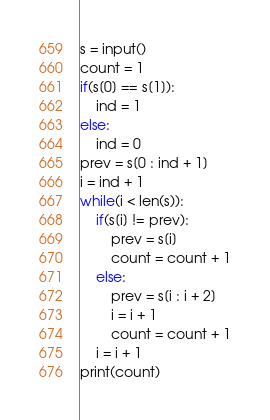Convert code to text. <code><loc_0><loc_0><loc_500><loc_500><_Python_>s = input()
count = 1
if(s[0] == s[1]):
    ind = 1
else:
    ind = 0
prev = s[0 : ind + 1]
i = ind + 1
while(i < len(s)):
    if(s[i] != prev):
        prev = s[i]
        count = count + 1
    else:
        prev = s[i : i + 2]
        i = i + 1
        count = count + 1
    i = i + 1
print(count)</code> 